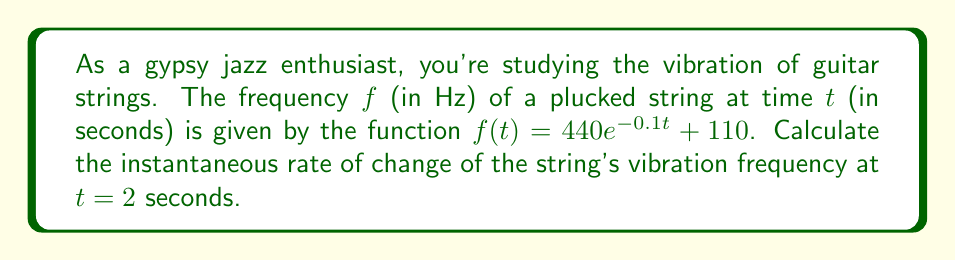What is the answer to this math problem? To find the instantaneous rate of change, we need to calculate the derivative of the function $f(t)$ and evaluate it at $t = 2$.

1. Given function: $f(t) = 440e^{-0.1t} + 110$

2. Calculate the derivative $f'(t)$ using the chain rule:
   $$f'(t) = 440 \cdot (-0.1) \cdot e^{-0.1t} + 0$$
   $$f'(t) = -44e^{-0.1t}$$

3. Evaluate $f'(t)$ at $t = 2$:
   $$f'(2) = -44e^{-0.1 \cdot 2}$$
   $$f'(2) = -44e^{-0.2}$$
   $$f'(2) = -44 \cdot 0.8187$$
   $$f'(2) = -36.02$$

4. Round to two decimal places: $-36.02$ Hz/s

The negative value indicates that the frequency is decreasing at this point in time.
Answer: $-36.02$ Hz/s 